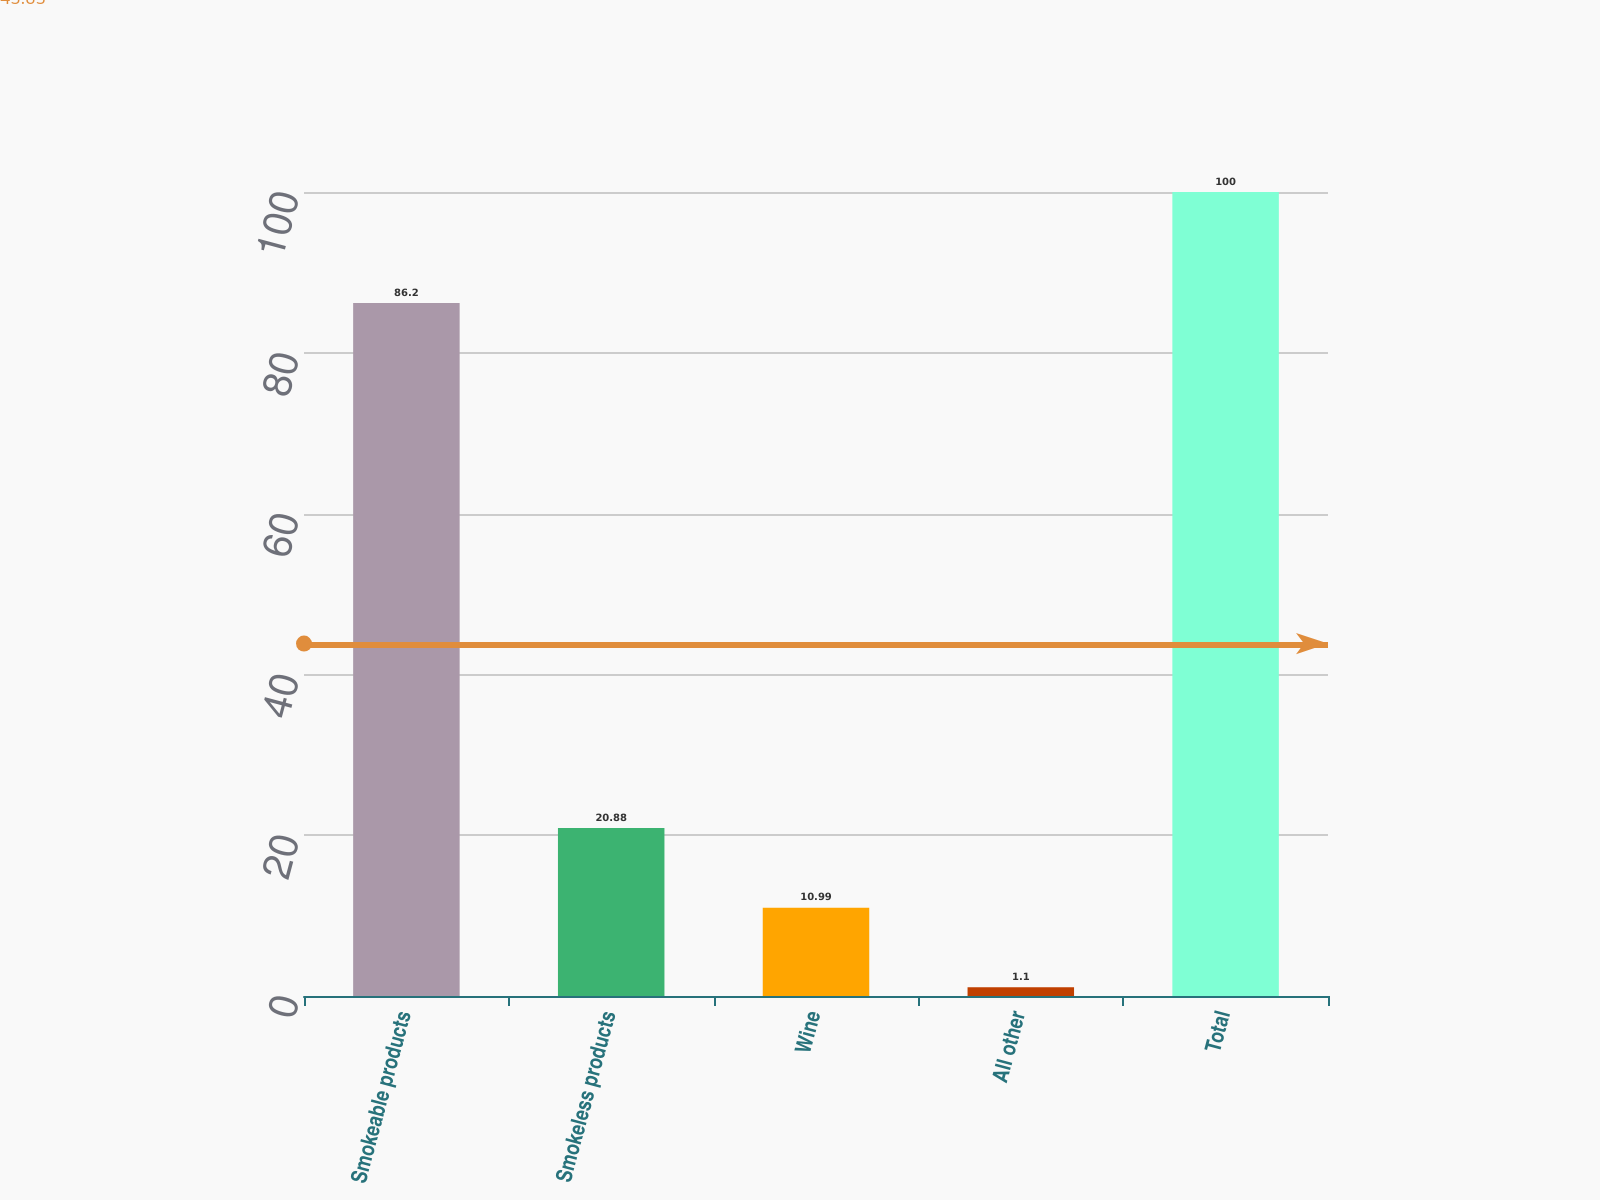Convert chart. <chart><loc_0><loc_0><loc_500><loc_500><bar_chart><fcel>Smokeable products<fcel>Smokeless products<fcel>Wine<fcel>All other<fcel>Total<nl><fcel>86.2<fcel>20.88<fcel>10.99<fcel>1.1<fcel>100<nl></chart> 